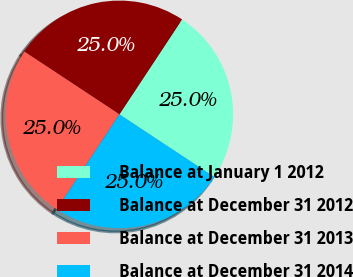Convert chart to OTSL. <chart><loc_0><loc_0><loc_500><loc_500><pie_chart><fcel>Balance at January 1 2012<fcel>Balance at December 31 2012<fcel>Balance at December 31 2013<fcel>Balance at December 31 2014<nl><fcel>25.0%<fcel>25.0%<fcel>25.0%<fcel>25.0%<nl></chart> 